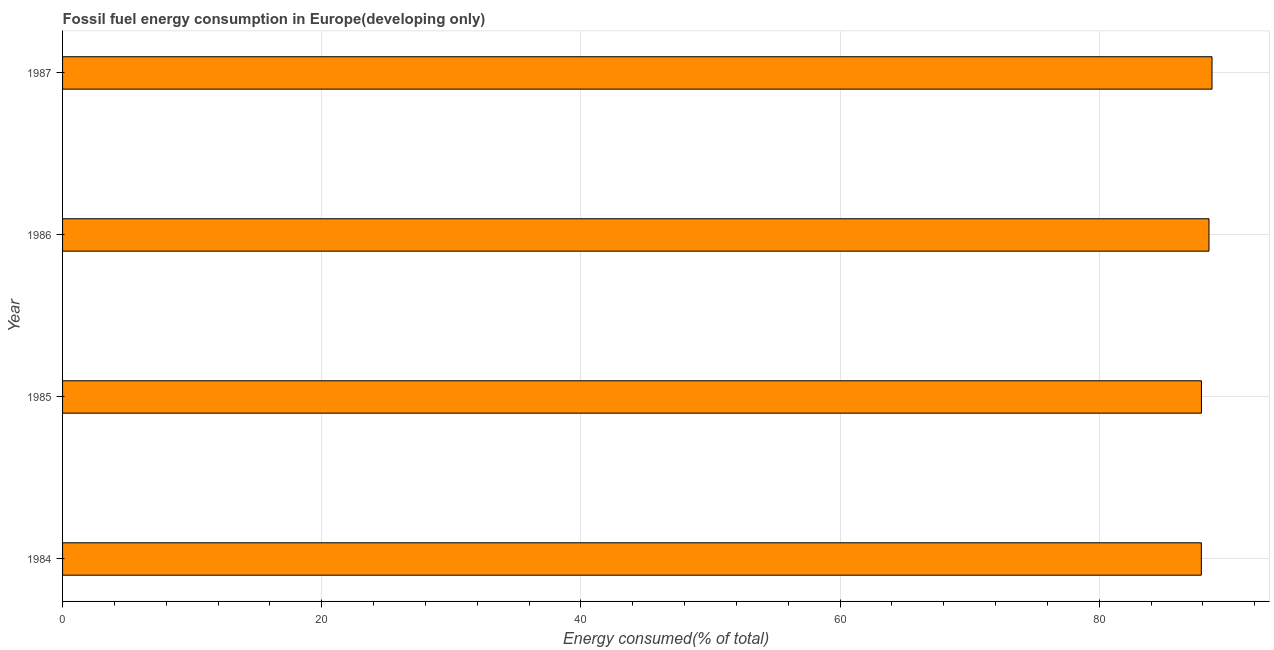Does the graph contain any zero values?
Offer a very short reply. No. What is the title of the graph?
Make the answer very short. Fossil fuel energy consumption in Europe(developing only). What is the label or title of the X-axis?
Offer a terse response. Energy consumed(% of total). What is the fossil fuel energy consumption in 1985?
Your answer should be compact. 87.89. Across all years, what is the maximum fossil fuel energy consumption?
Offer a very short reply. 88.7. Across all years, what is the minimum fossil fuel energy consumption?
Offer a very short reply. 87.88. In which year was the fossil fuel energy consumption minimum?
Offer a very short reply. 1984. What is the sum of the fossil fuel energy consumption?
Your answer should be compact. 352.93. What is the difference between the fossil fuel energy consumption in 1985 and 1987?
Give a very brief answer. -0.81. What is the average fossil fuel energy consumption per year?
Your answer should be compact. 88.23. What is the median fossil fuel energy consumption?
Offer a terse response. 88.18. Do a majority of the years between 1986 and 1987 (inclusive) have fossil fuel energy consumption greater than 84 %?
Your answer should be very brief. Yes. What is the ratio of the fossil fuel energy consumption in 1985 to that in 1986?
Your answer should be very brief. 0.99. What is the difference between the highest and the second highest fossil fuel energy consumption?
Your answer should be compact. 0.24. What is the difference between the highest and the lowest fossil fuel energy consumption?
Your answer should be very brief. 0.82. Are the values on the major ticks of X-axis written in scientific E-notation?
Offer a very short reply. No. What is the Energy consumed(% of total) in 1984?
Keep it short and to the point. 87.88. What is the Energy consumed(% of total) of 1985?
Keep it short and to the point. 87.89. What is the Energy consumed(% of total) of 1986?
Keep it short and to the point. 88.46. What is the Energy consumed(% of total) in 1987?
Offer a very short reply. 88.7. What is the difference between the Energy consumed(% of total) in 1984 and 1985?
Make the answer very short. -0.01. What is the difference between the Energy consumed(% of total) in 1984 and 1986?
Keep it short and to the point. -0.59. What is the difference between the Energy consumed(% of total) in 1984 and 1987?
Your answer should be very brief. -0.82. What is the difference between the Energy consumed(% of total) in 1985 and 1986?
Your answer should be very brief. -0.58. What is the difference between the Energy consumed(% of total) in 1985 and 1987?
Ensure brevity in your answer.  -0.82. What is the difference between the Energy consumed(% of total) in 1986 and 1987?
Ensure brevity in your answer.  -0.24. What is the ratio of the Energy consumed(% of total) in 1984 to that in 1986?
Provide a succinct answer. 0.99. What is the ratio of the Energy consumed(% of total) in 1984 to that in 1987?
Make the answer very short. 0.99. What is the ratio of the Energy consumed(% of total) in 1985 to that in 1986?
Keep it short and to the point. 0.99. What is the ratio of the Energy consumed(% of total) in 1985 to that in 1987?
Your answer should be very brief. 0.99. 